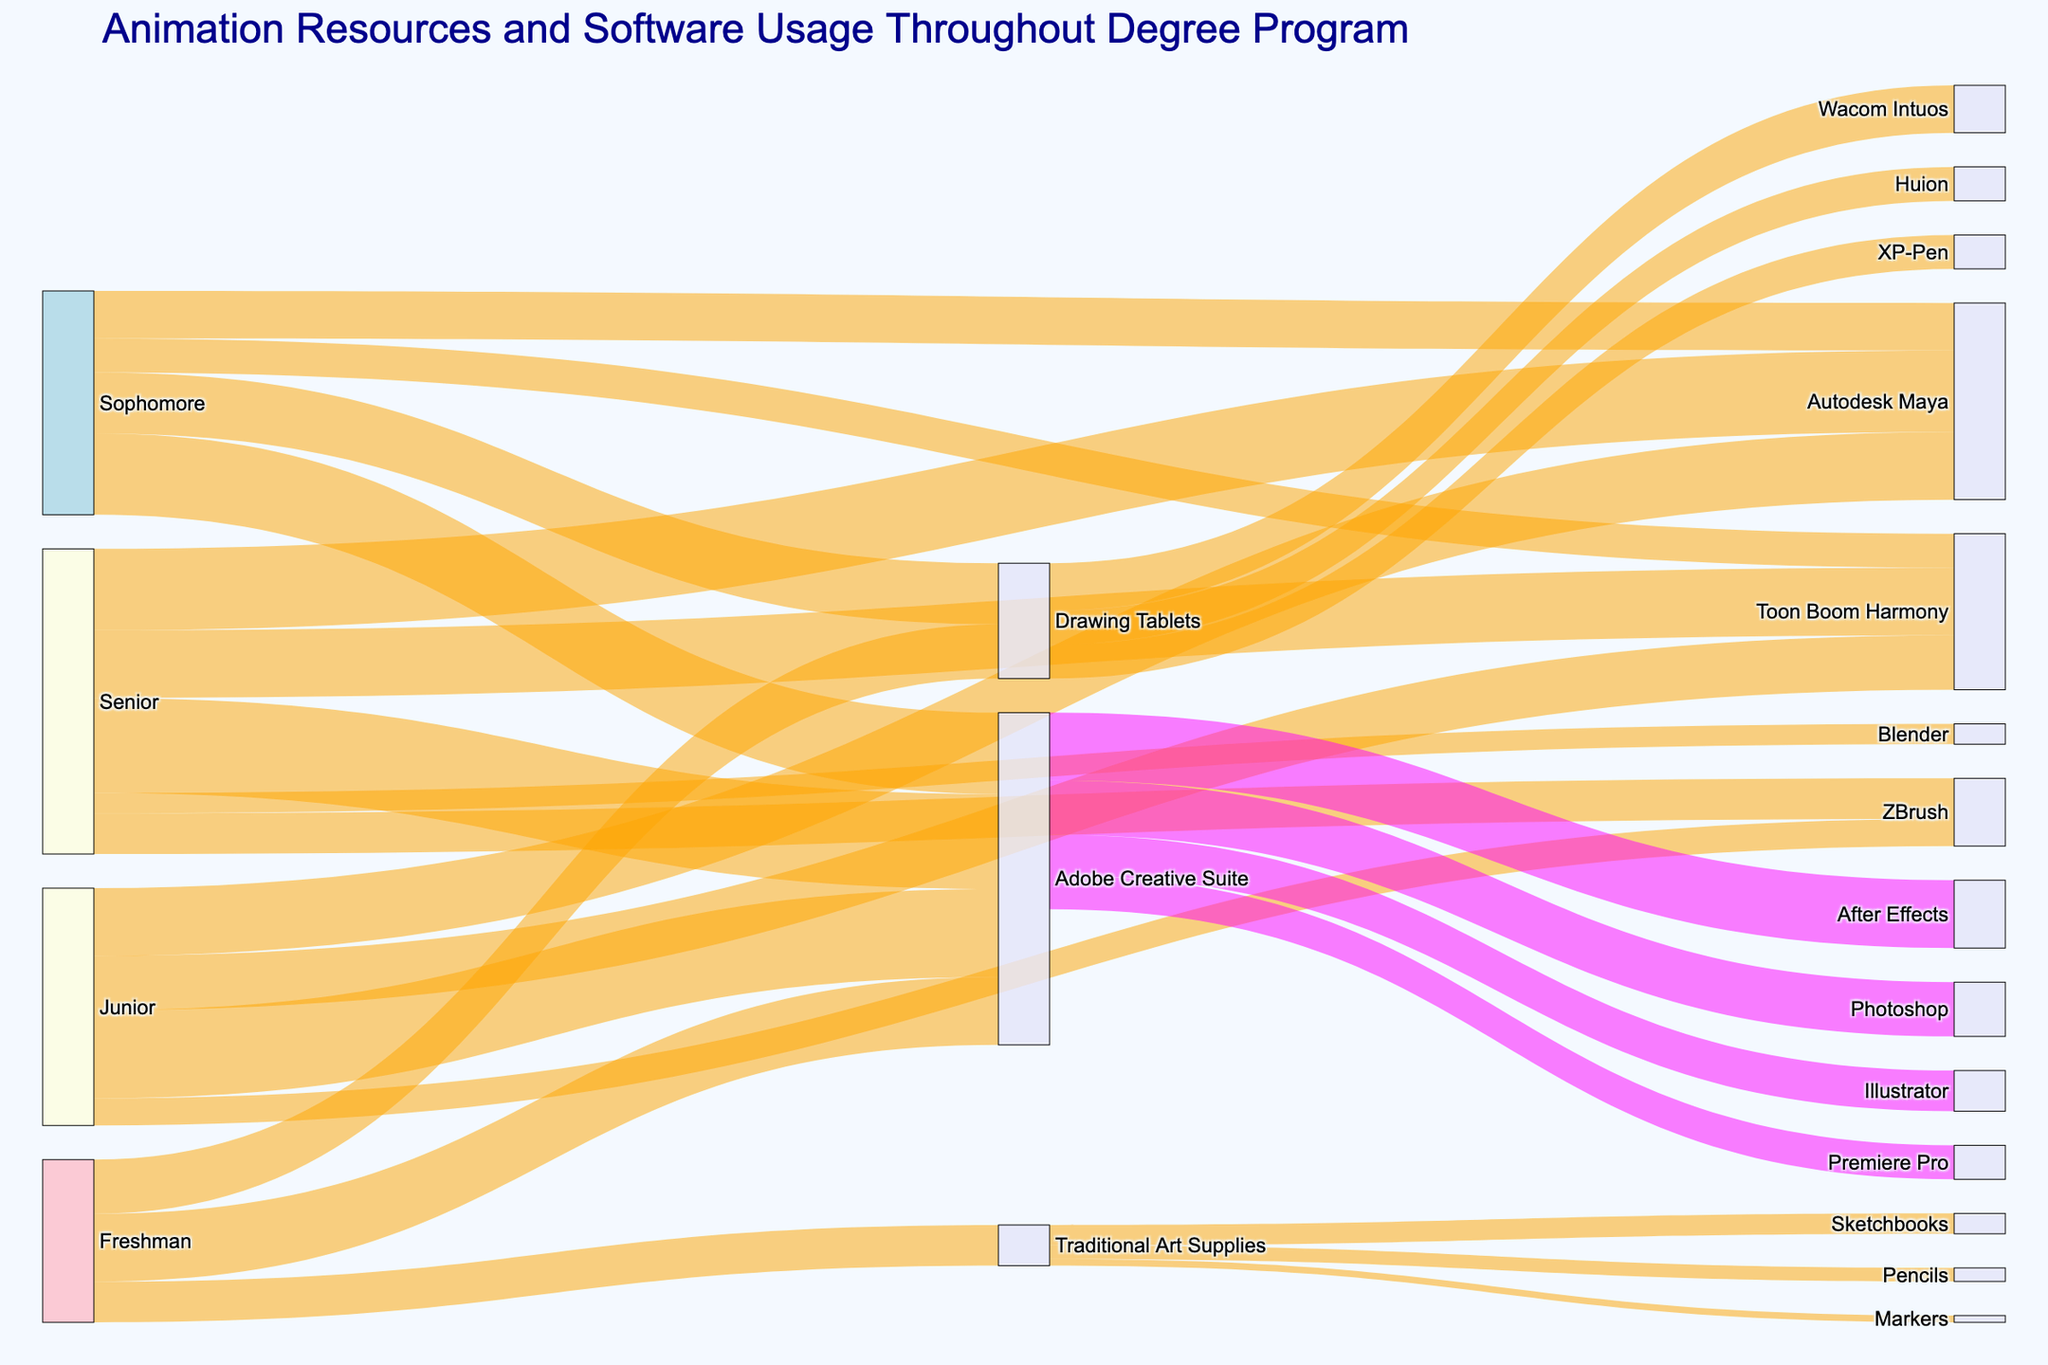what is the title of the Sankey diagram? The title is the most prominent text at the top of the figure, serving to summarize the main topic or purpose of the diagram. It helps viewers quickly understand what the figure represents.
Answer: Animation Resources and Software Usage Throughout Degree Program what resources do Freshman students predominantly use? The diagram shows the connections between nodes, with larger flows indicating higher usage. For Freshman students, the larger flows are connected to "Adobe Creative Suite," "Drawing Tablets," and "Traditional Art Supplies."
Answer: Adobe Creative Suite how does the usage of Autodesk Maya change from Sophomore to Senior year? The flows connected to "Autodesk Maya" in the Sophomore year and Senior year can be compared by their thickness. The value increases from 70 in the Sophomore year to 120 in the Senior year, indicating increased usage.
Answer: Increases which specific tools are used under Drawing Tablets? By following the flows from "Drawing Tablets" to their respective targets, we see connections to "Wacom Intuos," "Huion," and "XP-Pen."
Answer: Wacom Intuos, Huion, XP-Pen what are the tools used under Adobe Creative Suite? Each tool under "Adobe Creative Suite" is linked directly to it. The targets include "Photoshop," "Illustrator," "After Effects," and "Premiere Pro."
Answer: Photoshop, Illustrator, After Effects, Premiere Pro compare the usage of Toon Boom Harmony between Junior and Senior years. Examine the flows from "Junior" and "Senior" to "Toon Boom Harmony." The values show 80 for Junior and 100 for Senior, indicating an increase in usage.
Answer: Senior year has higher usage what is the sum of students using traditional art supplies across all years? Add up the values connected to "Traditional Art Supplies" from each entry: 60 (Freshman) + 0 (Sophomore) + 0 (Junior) + 0 (Senior).
Answer: 60 which drawing tablet brand is the most used according to the diagram? Compare the values of the flows from "Drawing Tablets" to each brand: "Wacom Intuos" (70), "Huion" (50), and "XP-Pen" (50). "Wacom Intuos" has the highest value.
Answer: Wacom Intuos how is the usage of ZBrush distributed across the academic years? The flows connected to "ZBrush" from each academic year show: 40 (Junior) and 60 (Senior).
Answer: Junior: 40, Senior: 60 which software receives the highest usage among all resources in the Senior year? Compare the values connected to each resource for the Senior year. "Adobe Creative Suite" has the highest value with 140.
Answer: Adobe Creative Suite 